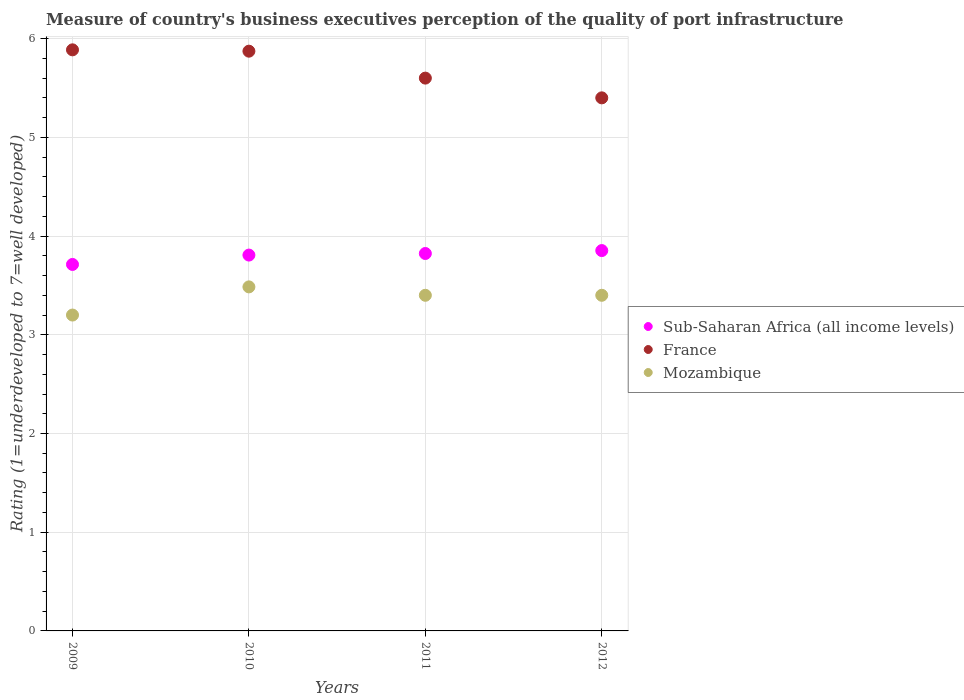How many different coloured dotlines are there?
Offer a very short reply. 3. What is the ratings of the quality of port infrastructure in Sub-Saharan Africa (all income levels) in 2012?
Your response must be concise. 3.85. Across all years, what is the maximum ratings of the quality of port infrastructure in Mozambique?
Keep it short and to the point. 3.49. Across all years, what is the minimum ratings of the quality of port infrastructure in Sub-Saharan Africa (all income levels)?
Offer a very short reply. 3.71. In which year was the ratings of the quality of port infrastructure in Mozambique maximum?
Make the answer very short. 2010. What is the total ratings of the quality of port infrastructure in Mozambique in the graph?
Provide a succinct answer. 13.48. What is the difference between the ratings of the quality of port infrastructure in Sub-Saharan Africa (all income levels) in 2010 and that in 2012?
Keep it short and to the point. -0.05. What is the difference between the ratings of the quality of port infrastructure in Mozambique in 2011 and the ratings of the quality of port infrastructure in Sub-Saharan Africa (all income levels) in 2009?
Keep it short and to the point. -0.31. What is the average ratings of the quality of port infrastructure in France per year?
Provide a succinct answer. 5.69. In the year 2009, what is the difference between the ratings of the quality of port infrastructure in Mozambique and ratings of the quality of port infrastructure in France?
Your response must be concise. -2.69. In how many years, is the ratings of the quality of port infrastructure in Sub-Saharan Africa (all income levels) greater than 4.2?
Provide a succinct answer. 0. What is the ratio of the ratings of the quality of port infrastructure in Sub-Saharan Africa (all income levels) in 2009 to that in 2011?
Give a very brief answer. 0.97. Is the ratings of the quality of port infrastructure in Mozambique in 2009 less than that in 2011?
Offer a terse response. Yes. What is the difference between the highest and the second highest ratings of the quality of port infrastructure in Mozambique?
Provide a succinct answer. 0.09. What is the difference between the highest and the lowest ratings of the quality of port infrastructure in France?
Offer a very short reply. 0.49. Is the sum of the ratings of the quality of port infrastructure in Sub-Saharan Africa (all income levels) in 2010 and 2012 greater than the maximum ratings of the quality of port infrastructure in France across all years?
Make the answer very short. Yes. How many years are there in the graph?
Your answer should be very brief. 4. Are the values on the major ticks of Y-axis written in scientific E-notation?
Keep it short and to the point. No. Does the graph contain any zero values?
Your answer should be very brief. No. Does the graph contain grids?
Give a very brief answer. Yes. Where does the legend appear in the graph?
Make the answer very short. Center right. How are the legend labels stacked?
Keep it short and to the point. Vertical. What is the title of the graph?
Offer a terse response. Measure of country's business executives perception of the quality of port infrastructure. What is the label or title of the X-axis?
Your answer should be compact. Years. What is the label or title of the Y-axis?
Make the answer very short. Rating (1=underdeveloped to 7=well developed). What is the Rating (1=underdeveloped to 7=well developed) in Sub-Saharan Africa (all income levels) in 2009?
Give a very brief answer. 3.71. What is the Rating (1=underdeveloped to 7=well developed) of France in 2009?
Ensure brevity in your answer.  5.89. What is the Rating (1=underdeveloped to 7=well developed) of Mozambique in 2009?
Your response must be concise. 3.2. What is the Rating (1=underdeveloped to 7=well developed) in Sub-Saharan Africa (all income levels) in 2010?
Offer a very short reply. 3.81. What is the Rating (1=underdeveloped to 7=well developed) of France in 2010?
Give a very brief answer. 5.87. What is the Rating (1=underdeveloped to 7=well developed) in Mozambique in 2010?
Provide a short and direct response. 3.49. What is the Rating (1=underdeveloped to 7=well developed) in Sub-Saharan Africa (all income levels) in 2011?
Give a very brief answer. 3.82. What is the Rating (1=underdeveloped to 7=well developed) in France in 2011?
Your answer should be very brief. 5.6. What is the Rating (1=underdeveloped to 7=well developed) of Sub-Saharan Africa (all income levels) in 2012?
Your answer should be very brief. 3.85. What is the Rating (1=underdeveloped to 7=well developed) of France in 2012?
Keep it short and to the point. 5.4. Across all years, what is the maximum Rating (1=underdeveloped to 7=well developed) of Sub-Saharan Africa (all income levels)?
Ensure brevity in your answer.  3.85. Across all years, what is the maximum Rating (1=underdeveloped to 7=well developed) in France?
Offer a terse response. 5.89. Across all years, what is the maximum Rating (1=underdeveloped to 7=well developed) in Mozambique?
Your answer should be very brief. 3.49. Across all years, what is the minimum Rating (1=underdeveloped to 7=well developed) in Sub-Saharan Africa (all income levels)?
Offer a very short reply. 3.71. Across all years, what is the minimum Rating (1=underdeveloped to 7=well developed) in France?
Give a very brief answer. 5.4. Across all years, what is the minimum Rating (1=underdeveloped to 7=well developed) in Mozambique?
Give a very brief answer. 3.2. What is the total Rating (1=underdeveloped to 7=well developed) in Sub-Saharan Africa (all income levels) in the graph?
Make the answer very short. 15.2. What is the total Rating (1=underdeveloped to 7=well developed) of France in the graph?
Provide a short and direct response. 22.76. What is the total Rating (1=underdeveloped to 7=well developed) in Mozambique in the graph?
Offer a terse response. 13.48. What is the difference between the Rating (1=underdeveloped to 7=well developed) in Sub-Saharan Africa (all income levels) in 2009 and that in 2010?
Make the answer very short. -0.09. What is the difference between the Rating (1=underdeveloped to 7=well developed) in France in 2009 and that in 2010?
Keep it short and to the point. 0.01. What is the difference between the Rating (1=underdeveloped to 7=well developed) in Mozambique in 2009 and that in 2010?
Offer a terse response. -0.29. What is the difference between the Rating (1=underdeveloped to 7=well developed) in Sub-Saharan Africa (all income levels) in 2009 and that in 2011?
Make the answer very short. -0.11. What is the difference between the Rating (1=underdeveloped to 7=well developed) in France in 2009 and that in 2011?
Offer a very short reply. 0.29. What is the difference between the Rating (1=underdeveloped to 7=well developed) in Mozambique in 2009 and that in 2011?
Make the answer very short. -0.2. What is the difference between the Rating (1=underdeveloped to 7=well developed) in Sub-Saharan Africa (all income levels) in 2009 and that in 2012?
Provide a short and direct response. -0.14. What is the difference between the Rating (1=underdeveloped to 7=well developed) of France in 2009 and that in 2012?
Give a very brief answer. 0.49. What is the difference between the Rating (1=underdeveloped to 7=well developed) of Mozambique in 2009 and that in 2012?
Ensure brevity in your answer.  -0.2. What is the difference between the Rating (1=underdeveloped to 7=well developed) of Sub-Saharan Africa (all income levels) in 2010 and that in 2011?
Provide a succinct answer. -0.02. What is the difference between the Rating (1=underdeveloped to 7=well developed) of France in 2010 and that in 2011?
Offer a very short reply. 0.27. What is the difference between the Rating (1=underdeveloped to 7=well developed) in Mozambique in 2010 and that in 2011?
Provide a short and direct response. 0.09. What is the difference between the Rating (1=underdeveloped to 7=well developed) of Sub-Saharan Africa (all income levels) in 2010 and that in 2012?
Give a very brief answer. -0.05. What is the difference between the Rating (1=underdeveloped to 7=well developed) of France in 2010 and that in 2012?
Offer a terse response. 0.47. What is the difference between the Rating (1=underdeveloped to 7=well developed) in Mozambique in 2010 and that in 2012?
Offer a very short reply. 0.09. What is the difference between the Rating (1=underdeveloped to 7=well developed) of Sub-Saharan Africa (all income levels) in 2011 and that in 2012?
Ensure brevity in your answer.  -0.03. What is the difference between the Rating (1=underdeveloped to 7=well developed) of Sub-Saharan Africa (all income levels) in 2009 and the Rating (1=underdeveloped to 7=well developed) of France in 2010?
Make the answer very short. -2.16. What is the difference between the Rating (1=underdeveloped to 7=well developed) in Sub-Saharan Africa (all income levels) in 2009 and the Rating (1=underdeveloped to 7=well developed) in Mozambique in 2010?
Your answer should be very brief. 0.23. What is the difference between the Rating (1=underdeveloped to 7=well developed) in France in 2009 and the Rating (1=underdeveloped to 7=well developed) in Mozambique in 2010?
Make the answer very short. 2.4. What is the difference between the Rating (1=underdeveloped to 7=well developed) in Sub-Saharan Africa (all income levels) in 2009 and the Rating (1=underdeveloped to 7=well developed) in France in 2011?
Offer a very short reply. -1.89. What is the difference between the Rating (1=underdeveloped to 7=well developed) in Sub-Saharan Africa (all income levels) in 2009 and the Rating (1=underdeveloped to 7=well developed) in Mozambique in 2011?
Ensure brevity in your answer.  0.31. What is the difference between the Rating (1=underdeveloped to 7=well developed) of France in 2009 and the Rating (1=underdeveloped to 7=well developed) of Mozambique in 2011?
Keep it short and to the point. 2.49. What is the difference between the Rating (1=underdeveloped to 7=well developed) of Sub-Saharan Africa (all income levels) in 2009 and the Rating (1=underdeveloped to 7=well developed) of France in 2012?
Your response must be concise. -1.69. What is the difference between the Rating (1=underdeveloped to 7=well developed) in Sub-Saharan Africa (all income levels) in 2009 and the Rating (1=underdeveloped to 7=well developed) in Mozambique in 2012?
Provide a short and direct response. 0.31. What is the difference between the Rating (1=underdeveloped to 7=well developed) in France in 2009 and the Rating (1=underdeveloped to 7=well developed) in Mozambique in 2012?
Make the answer very short. 2.49. What is the difference between the Rating (1=underdeveloped to 7=well developed) of Sub-Saharan Africa (all income levels) in 2010 and the Rating (1=underdeveloped to 7=well developed) of France in 2011?
Your answer should be compact. -1.79. What is the difference between the Rating (1=underdeveloped to 7=well developed) of Sub-Saharan Africa (all income levels) in 2010 and the Rating (1=underdeveloped to 7=well developed) of Mozambique in 2011?
Make the answer very short. 0.41. What is the difference between the Rating (1=underdeveloped to 7=well developed) of France in 2010 and the Rating (1=underdeveloped to 7=well developed) of Mozambique in 2011?
Ensure brevity in your answer.  2.47. What is the difference between the Rating (1=underdeveloped to 7=well developed) of Sub-Saharan Africa (all income levels) in 2010 and the Rating (1=underdeveloped to 7=well developed) of France in 2012?
Your response must be concise. -1.59. What is the difference between the Rating (1=underdeveloped to 7=well developed) of Sub-Saharan Africa (all income levels) in 2010 and the Rating (1=underdeveloped to 7=well developed) of Mozambique in 2012?
Your answer should be very brief. 0.41. What is the difference between the Rating (1=underdeveloped to 7=well developed) in France in 2010 and the Rating (1=underdeveloped to 7=well developed) in Mozambique in 2012?
Offer a very short reply. 2.47. What is the difference between the Rating (1=underdeveloped to 7=well developed) of Sub-Saharan Africa (all income levels) in 2011 and the Rating (1=underdeveloped to 7=well developed) of France in 2012?
Offer a terse response. -1.58. What is the difference between the Rating (1=underdeveloped to 7=well developed) of Sub-Saharan Africa (all income levels) in 2011 and the Rating (1=underdeveloped to 7=well developed) of Mozambique in 2012?
Offer a terse response. 0.42. What is the average Rating (1=underdeveloped to 7=well developed) of Sub-Saharan Africa (all income levels) per year?
Your answer should be compact. 3.8. What is the average Rating (1=underdeveloped to 7=well developed) of France per year?
Your answer should be very brief. 5.69. What is the average Rating (1=underdeveloped to 7=well developed) in Mozambique per year?
Make the answer very short. 3.37. In the year 2009, what is the difference between the Rating (1=underdeveloped to 7=well developed) of Sub-Saharan Africa (all income levels) and Rating (1=underdeveloped to 7=well developed) of France?
Offer a terse response. -2.17. In the year 2009, what is the difference between the Rating (1=underdeveloped to 7=well developed) in Sub-Saharan Africa (all income levels) and Rating (1=underdeveloped to 7=well developed) in Mozambique?
Give a very brief answer. 0.51. In the year 2009, what is the difference between the Rating (1=underdeveloped to 7=well developed) in France and Rating (1=underdeveloped to 7=well developed) in Mozambique?
Give a very brief answer. 2.69. In the year 2010, what is the difference between the Rating (1=underdeveloped to 7=well developed) of Sub-Saharan Africa (all income levels) and Rating (1=underdeveloped to 7=well developed) of France?
Your response must be concise. -2.07. In the year 2010, what is the difference between the Rating (1=underdeveloped to 7=well developed) in Sub-Saharan Africa (all income levels) and Rating (1=underdeveloped to 7=well developed) in Mozambique?
Give a very brief answer. 0.32. In the year 2010, what is the difference between the Rating (1=underdeveloped to 7=well developed) in France and Rating (1=underdeveloped to 7=well developed) in Mozambique?
Your response must be concise. 2.39. In the year 2011, what is the difference between the Rating (1=underdeveloped to 7=well developed) of Sub-Saharan Africa (all income levels) and Rating (1=underdeveloped to 7=well developed) of France?
Give a very brief answer. -1.78. In the year 2011, what is the difference between the Rating (1=underdeveloped to 7=well developed) in Sub-Saharan Africa (all income levels) and Rating (1=underdeveloped to 7=well developed) in Mozambique?
Your answer should be very brief. 0.42. In the year 2012, what is the difference between the Rating (1=underdeveloped to 7=well developed) of Sub-Saharan Africa (all income levels) and Rating (1=underdeveloped to 7=well developed) of France?
Provide a short and direct response. -1.55. In the year 2012, what is the difference between the Rating (1=underdeveloped to 7=well developed) of Sub-Saharan Africa (all income levels) and Rating (1=underdeveloped to 7=well developed) of Mozambique?
Provide a succinct answer. 0.45. In the year 2012, what is the difference between the Rating (1=underdeveloped to 7=well developed) in France and Rating (1=underdeveloped to 7=well developed) in Mozambique?
Make the answer very short. 2. What is the ratio of the Rating (1=underdeveloped to 7=well developed) in Sub-Saharan Africa (all income levels) in 2009 to that in 2010?
Your answer should be compact. 0.98. What is the ratio of the Rating (1=underdeveloped to 7=well developed) in Mozambique in 2009 to that in 2010?
Your answer should be compact. 0.92. What is the ratio of the Rating (1=underdeveloped to 7=well developed) in Sub-Saharan Africa (all income levels) in 2009 to that in 2011?
Make the answer very short. 0.97. What is the ratio of the Rating (1=underdeveloped to 7=well developed) of France in 2009 to that in 2011?
Offer a very short reply. 1.05. What is the ratio of the Rating (1=underdeveloped to 7=well developed) in Mozambique in 2009 to that in 2011?
Keep it short and to the point. 0.94. What is the ratio of the Rating (1=underdeveloped to 7=well developed) of Sub-Saharan Africa (all income levels) in 2009 to that in 2012?
Your answer should be compact. 0.96. What is the ratio of the Rating (1=underdeveloped to 7=well developed) in France in 2009 to that in 2012?
Your response must be concise. 1.09. What is the ratio of the Rating (1=underdeveloped to 7=well developed) in Mozambique in 2009 to that in 2012?
Provide a short and direct response. 0.94. What is the ratio of the Rating (1=underdeveloped to 7=well developed) in Sub-Saharan Africa (all income levels) in 2010 to that in 2011?
Offer a terse response. 1. What is the ratio of the Rating (1=underdeveloped to 7=well developed) of France in 2010 to that in 2011?
Keep it short and to the point. 1.05. What is the ratio of the Rating (1=underdeveloped to 7=well developed) in Sub-Saharan Africa (all income levels) in 2010 to that in 2012?
Provide a short and direct response. 0.99. What is the ratio of the Rating (1=underdeveloped to 7=well developed) in France in 2010 to that in 2012?
Your response must be concise. 1.09. What is the ratio of the Rating (1=underdeveloped to 7=well developed) in Mozambique in 2011 to that in 2012?
Give a very brief answer. 1. What is the difference between the highest and the second highest Rating (1=underdeveloped to 7=well developed) in Sub-Saharan Africa (all income levels)?
Keep it short and to the point. 0.03. What is the difference between the highest and the second highest Rating (1=underdeveloped to 7=well developed) of France?
Give a very brief answer. 0.01. What is the difference between the highest and the second highest Rating (1=underdeveloped to 7=well developed) of Mozambique?
Provide a succinct answer. 0.09. What is the difference between the highest and the lowest Rating (1=underdeveloped to 7=well developed) in Sub-Saharan Africa (all income levels)?
Offer a very short reply. 0.14. What is the difference between the highest and the lowest Rating (1=underdeveloped to 7=well developed) in France?
Provide a short and direct response. 0.49. What is the difference between the highest and the lowest Rating (1=underdeveloped to 7=well developed) of Mozambique?
Provide a short and direct response. 0.29. 